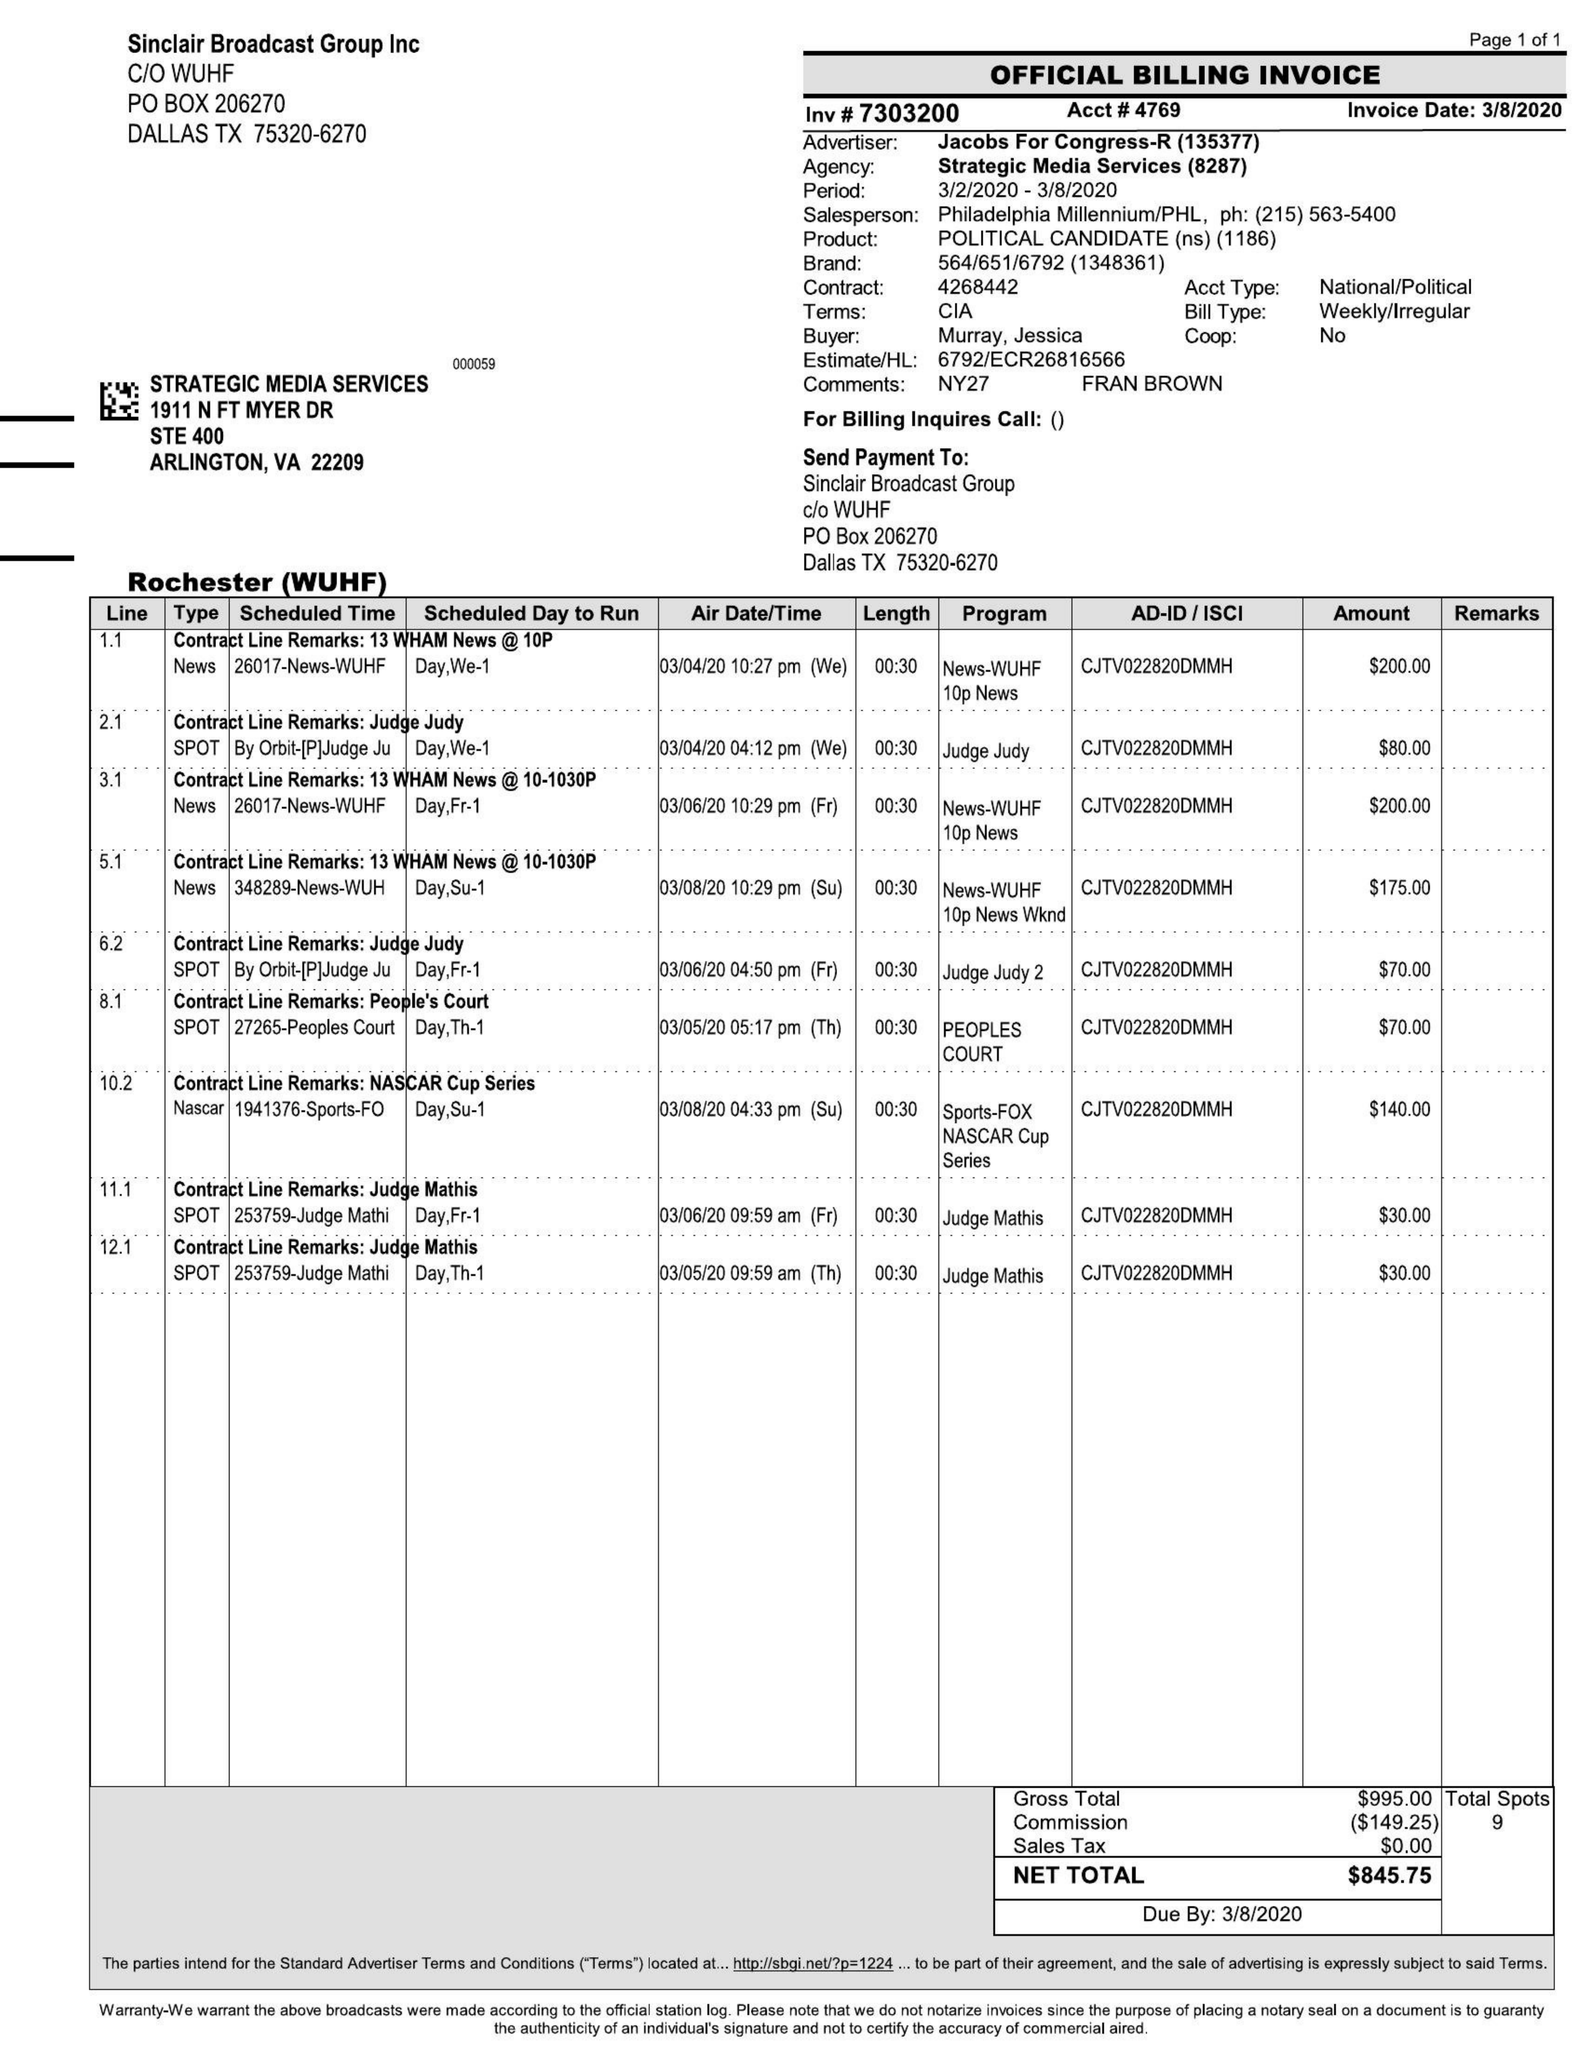What is the value for the advertiser?
Answer the question using a single word or phrase. JACOBS FOR CONGRESS-R 